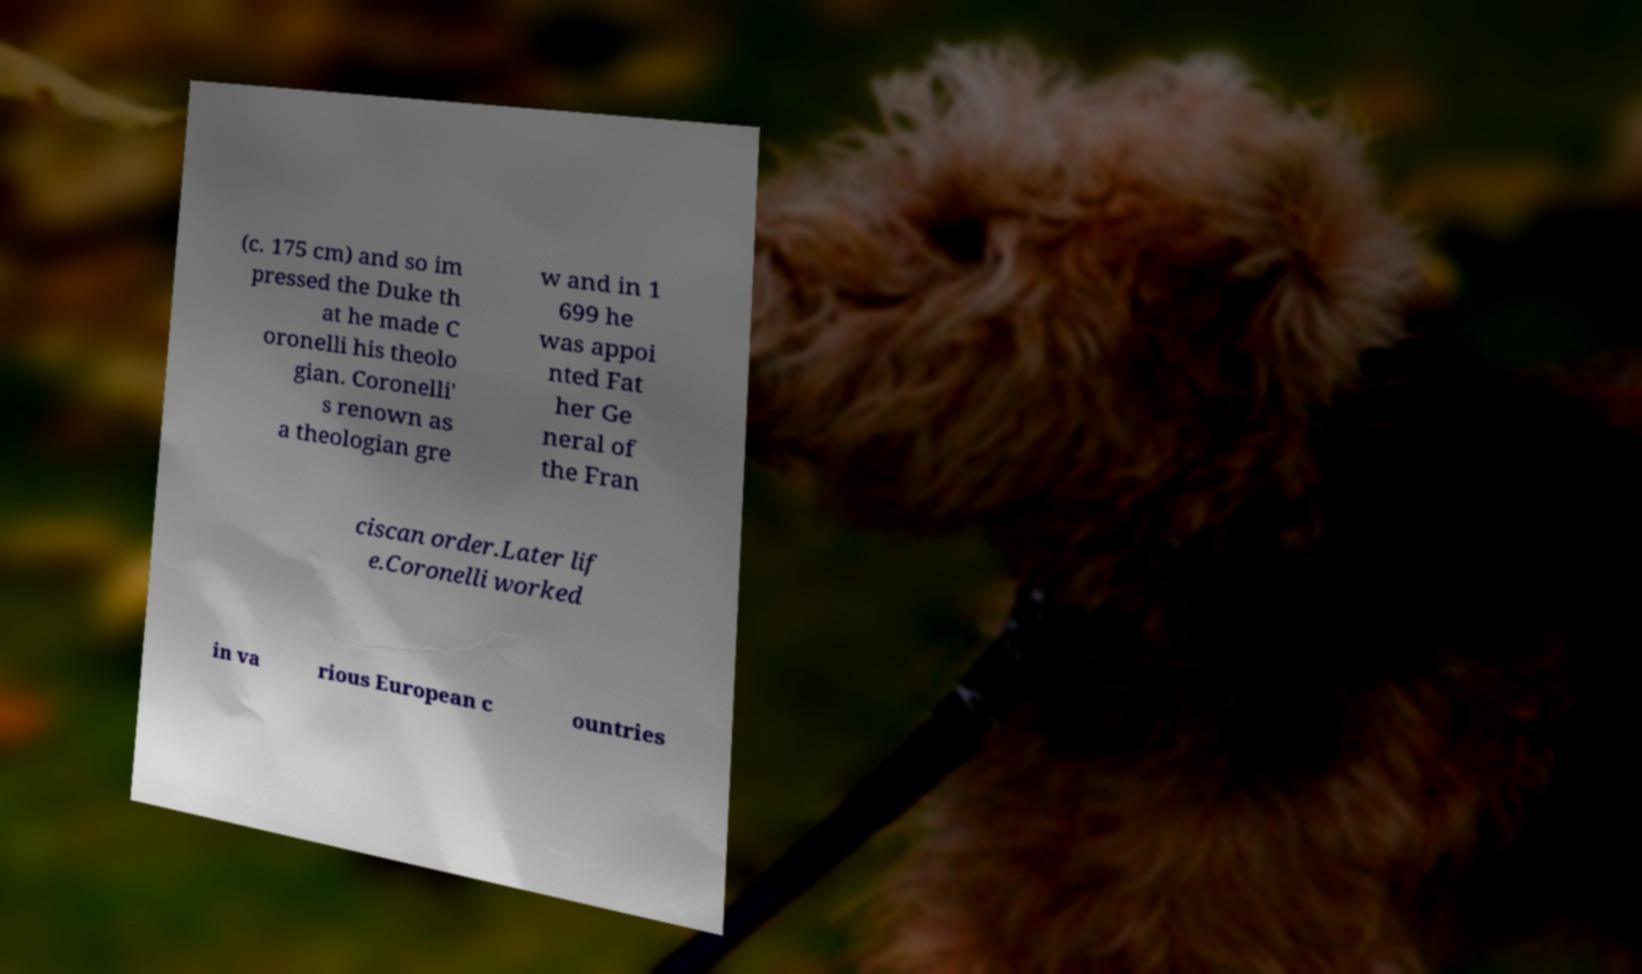I need the written content from this picture converted into text. Can you do that? (c. 175 cm) and so im pressed the Duke th at he made C oronelli his theolo gian. Coronelli' s renown as a theologian gre w and in 1 699 he was appoi nted Fat her Ge neral of the Fran ciscan order.Later lif e.Coronelli worked in va rious European c ountries 